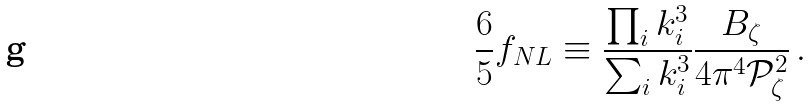Convert formula to latex. <formula><loc_0><loc_0><loc_500><loc_500>\frac { 6 } { 5 } f _ { N L } \equiv \frac { \prod _ { i } k _ { i } ^ { 3 } } { \sum _ { i } k _ { i } ^ { 3 } } \frac { B _ { \zeta } } { 4 \pi ^ { 4 } \mathcal { P } _ { \zeta } ^ { 2 } } \, .</formula> 